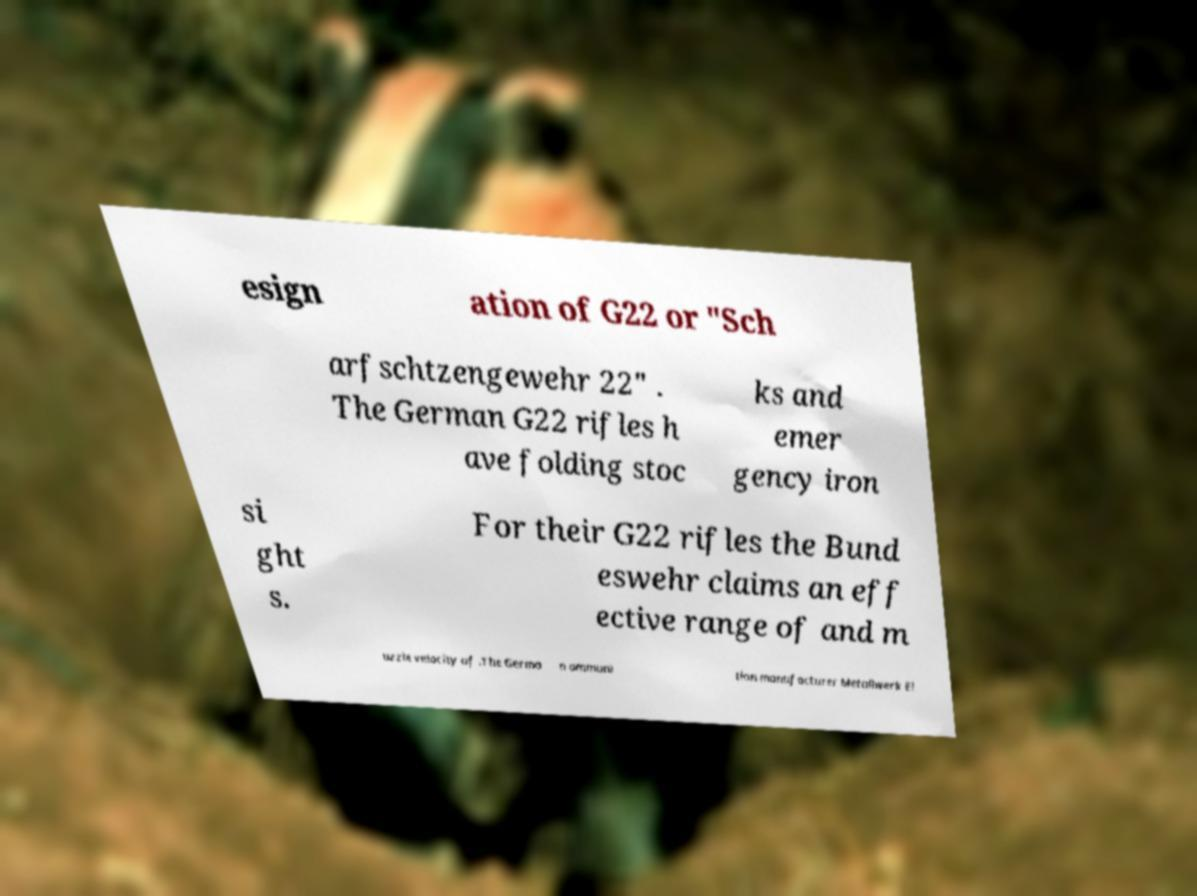What messages or text are displayed in this image? I need them in a readable, typed format. esign ation of G22 or "Sch arfschtzengewehr 22" . The German G22 rifles h ave folding stoc ks and emer gency iron si ght s. For their G22 rifles the Bund eswehr claims an eff ective range of and m uzzle velocity of .The Germa n ammuni tion manufacturer Metallwerk El 